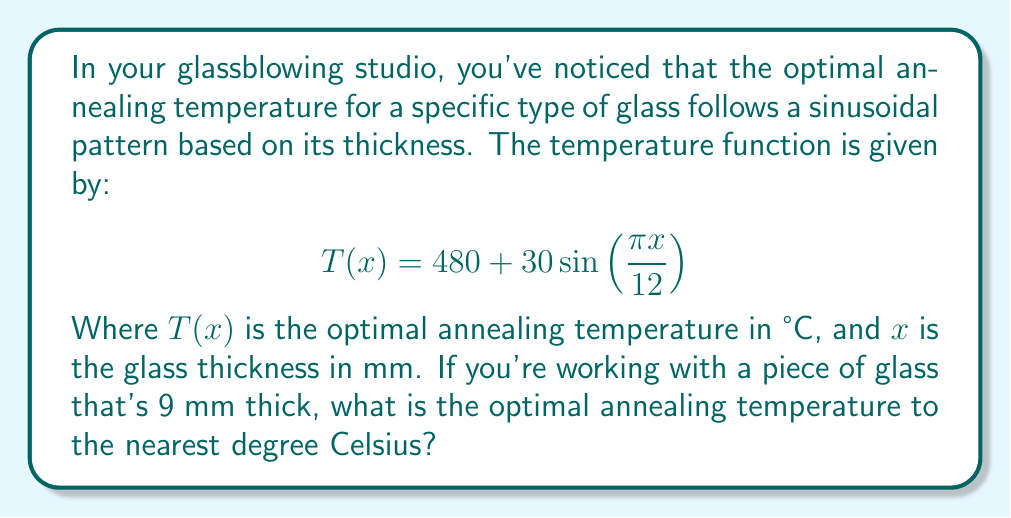Provide a solution to this math problem. Let's approach this step-by-step:

1) We're given the function:
   $$T(x) = 480 + 30\sin(\frac{\pi x}{12})$$

2) We need to find $T(9)$, as the glass thickness is 9 mm.

3) Let's substitute $x = 9$ into the function:
   $$T(9) = 480 + 30\sin(\frac{\pi \cdot 9}{12})$$

4) Simplify the fraction inside the sine function:
   $$T(9) = 480 + 30\sin(\frac{3\pi}{4})$$

5) Recall that $\sin(\frac{3\pi}{4}) = \frac{\sqrt{2}}{2}$

6) Substitute this value:
   $$T(9) = 480 + 30 \cdot \frac{\sqrt{2}}{2}$$

7) Simplify:
   $$T(9) = 480 + 15\sqrt{2}$$

8) Calculate the value (you can use a calculator for this):
   $$T(9) \approx 480 + 21.21 = 501.21$$

9) Rounding to the nearest degree:
   $$T(9) \approx 501°C$$
Answer: The optimal annealing temperature for a 9 mm thick piece of glass is 501°C. 